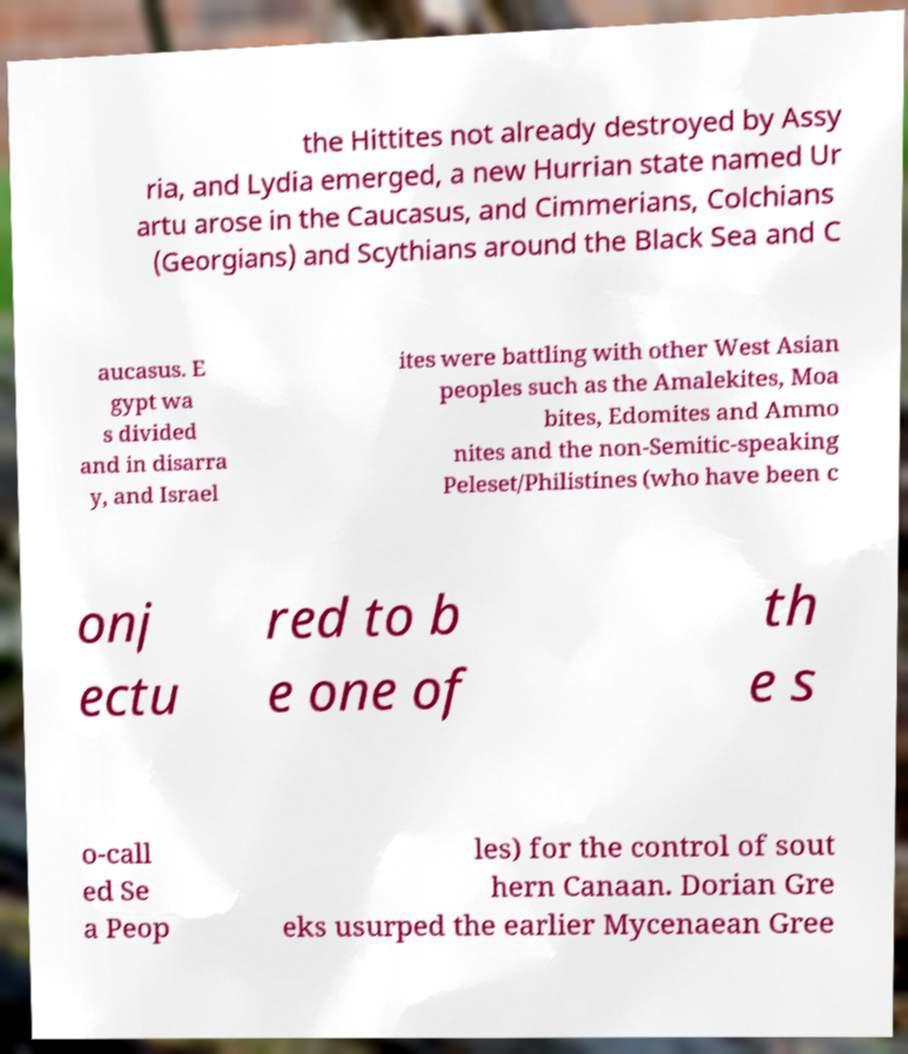I need the written content from this picture converted into text. Can you do that? the Hittites not already destroyed by Assy ria, and Lydia emerged, a new Hurrian state named Ur artu arose in the Caucasus, and Cimmerians, Colchians (Georgians) and Scythians around the Black Sea and C aucasus. E gypt wa s divided and in disarra y, and Israel ites were battling with other West Asian peoples such as the Amalekites, Moa bites, Edomites and Ammo nites and the non-Semitic-speaking Peleset/Philistines (who have been c onj ectu red to b e one of th e s o-call ed Se a Peop les) for the control of sout hern Canaan. Dorian Gre eks usurped the earlier Mycenaean Gree 